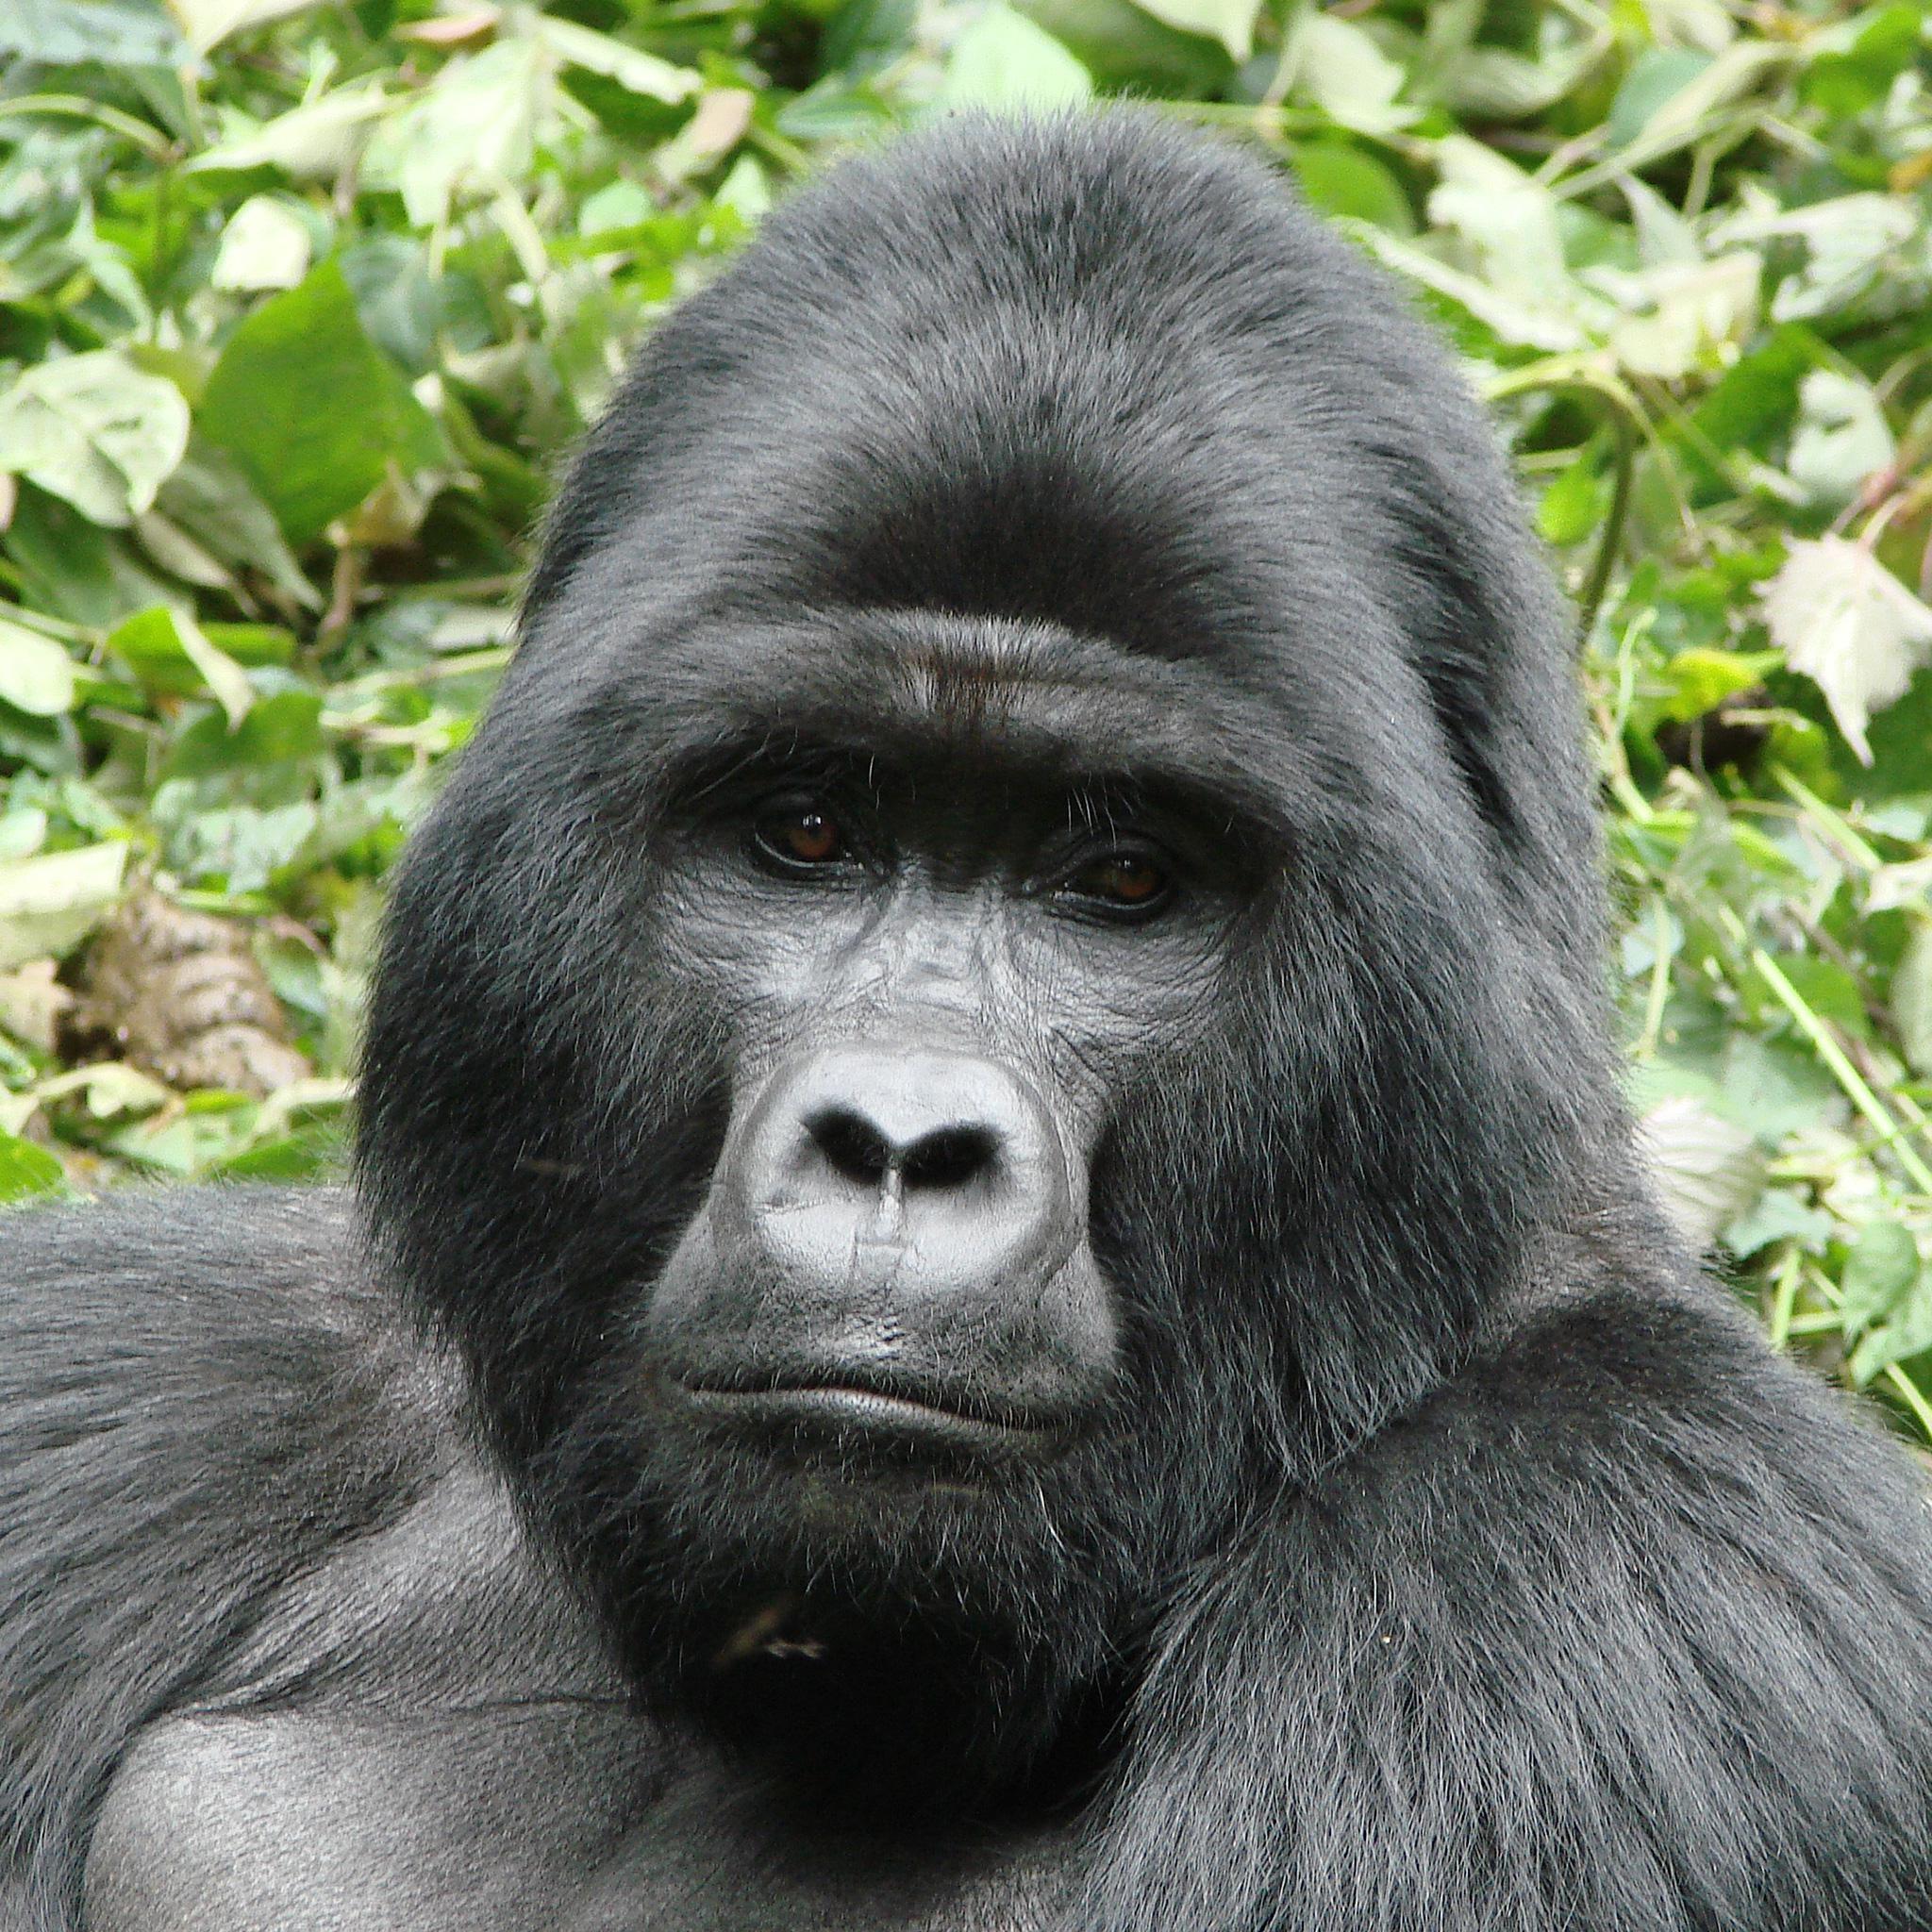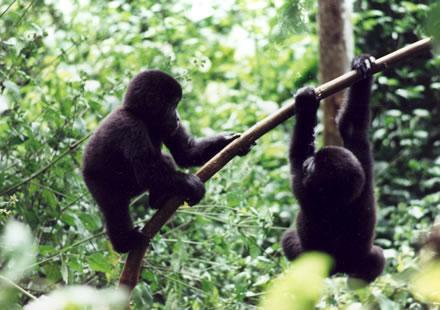The first image is the image on the left, the second image is the image on the right. For the images shown, is this caption "There are no more than two gorillas in the right image." true? Answer yes or no. Yes. The first image is the image on the left, the second image is the image on the right. Evaluate the accuracy of this statement regarding the images: "There are adult and juvenile gorillas in each image.". Is it true? Answer yes or no. No. 